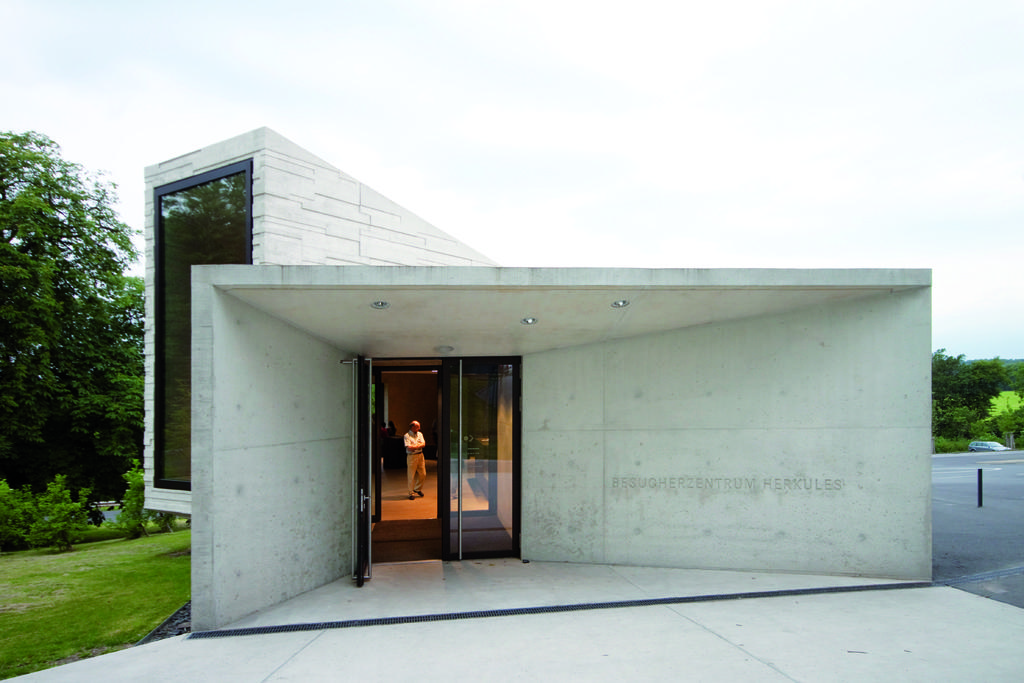Where is the person located in the image? The person is standing in a building. What type of vegetation can be seen in the image? There are many trees in the image. What is the ground covered with? The ground is covered with grass. What type of butter is being used to make a discovery in the image? There is no butter or discovery present in the image. How old is the baby in the image? There is no baby present in the image. 